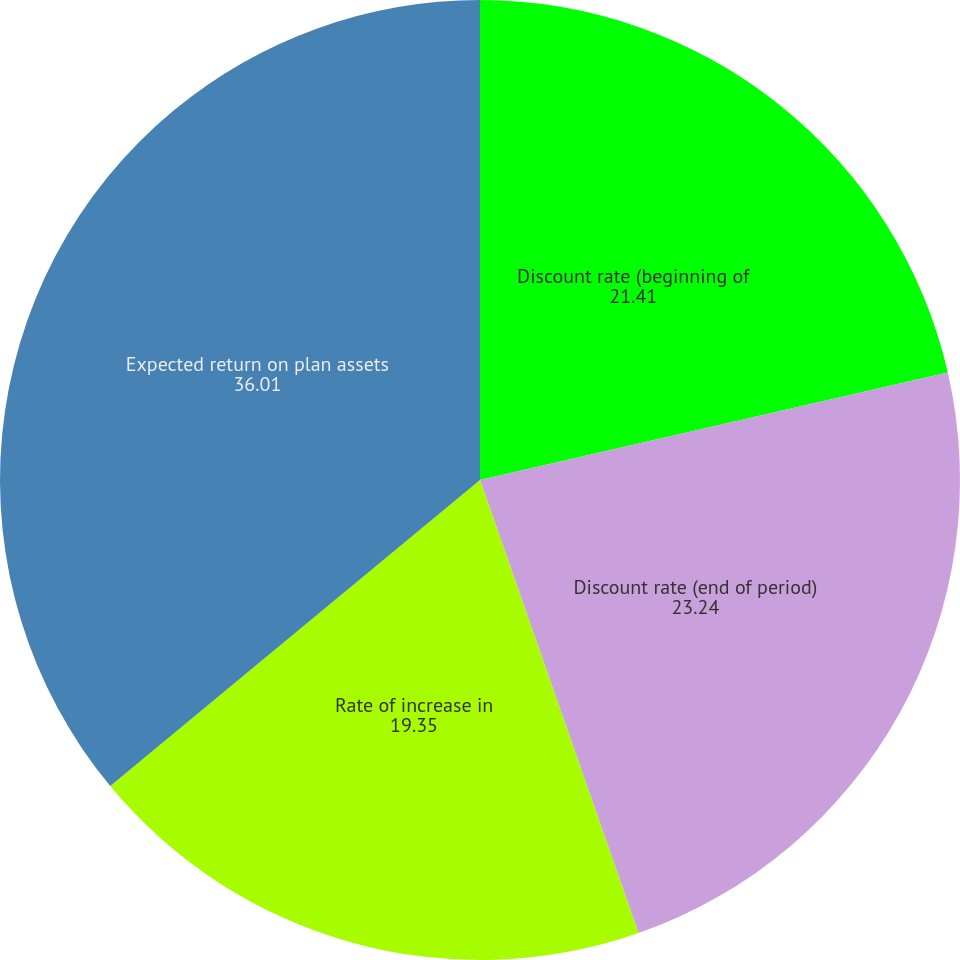Convert chart to OTSL. <chart><loc_0><loc_0><loc_500><loc_500><pie_chart><fcel>Discount rate (beginning of<fcel>Discount rate (end of period)<fcel>Rate of increase in<fcel>Expected return on plan assets<nl><fcel>21.41%<fcel>23.24%<fcel>19.35%<fcel>36.01%<nl></chart> 